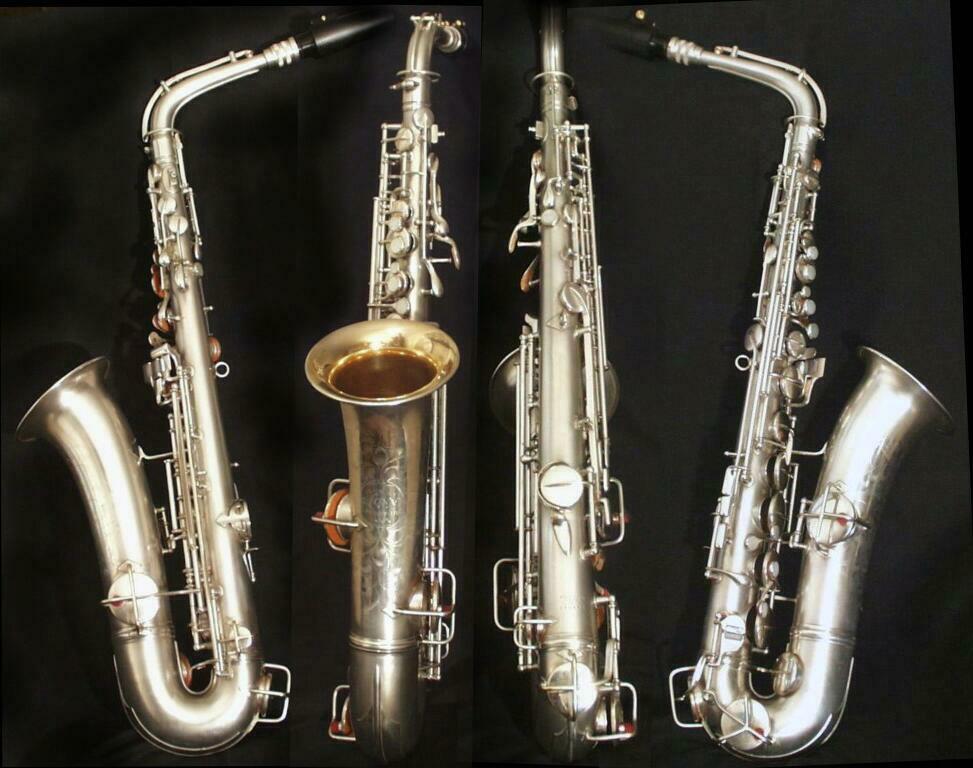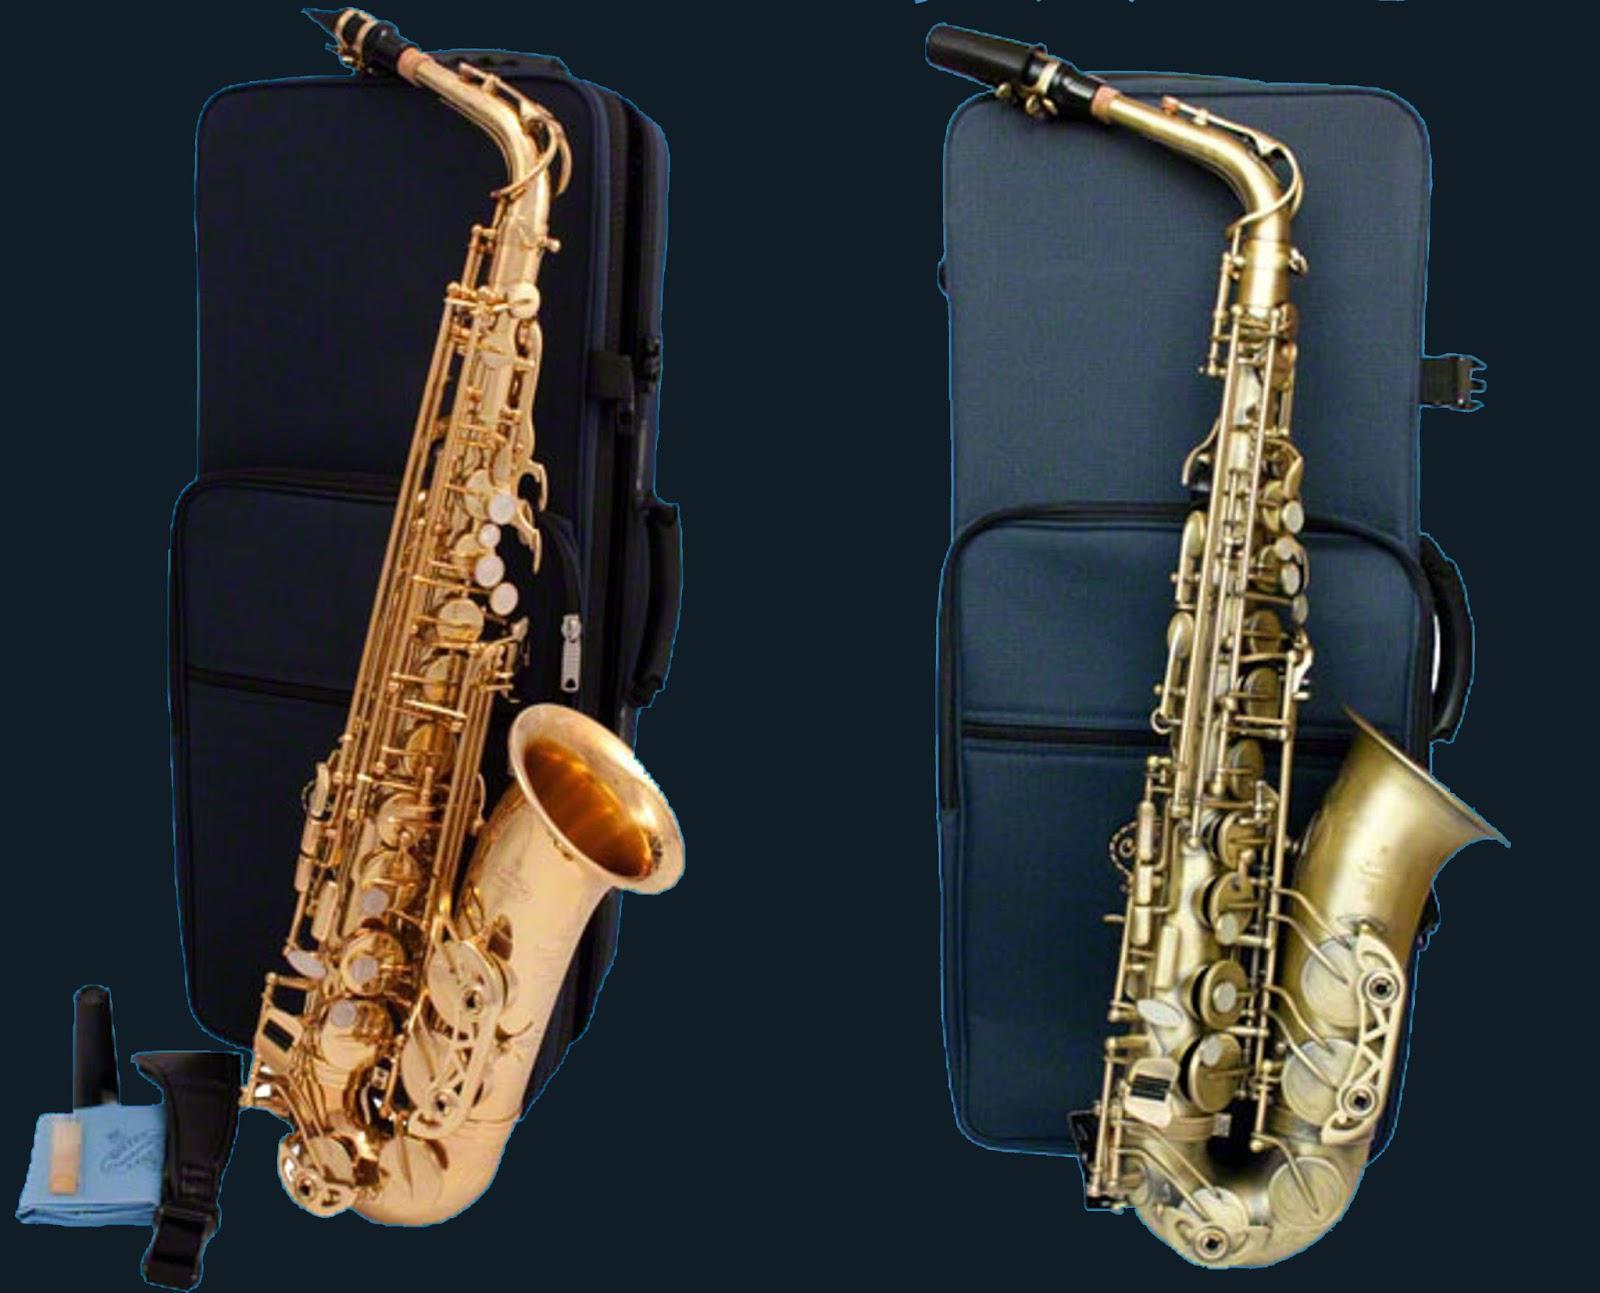The first image is the image on the left, the second image is the image on the right. Analyze the images presented: Is the assertion "Four instruments are lined up together in the image on the left." valid? Answer yes or no. Yes. The first image is the image on the left, the second image is the image on the right. Analyze the images presented: Is the assertion "Right and left images each show four instruments, including one that is straight and three with curved mouthpieces and bell ends." valid? Answer yes or no. No. 